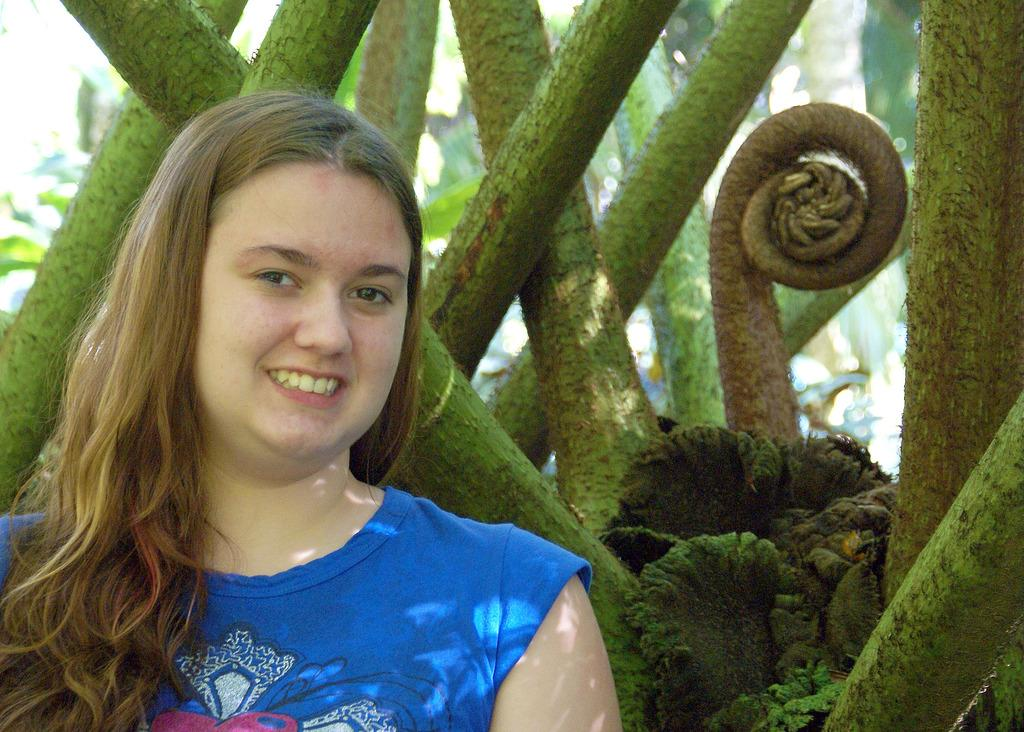Who is present in the image? There is a woman in the image. What is the woman wearing? The woman is wearing a blue dress. What can be seen in the background of the image? There is a group of plants in the background of the image. How many cherries are on the woman's head in the image? There are no cherries present on the woman's head in the image. What type of rings can be seen on the woman's fingers in the image? There are no rings visible on the woman's fingers in the image. 